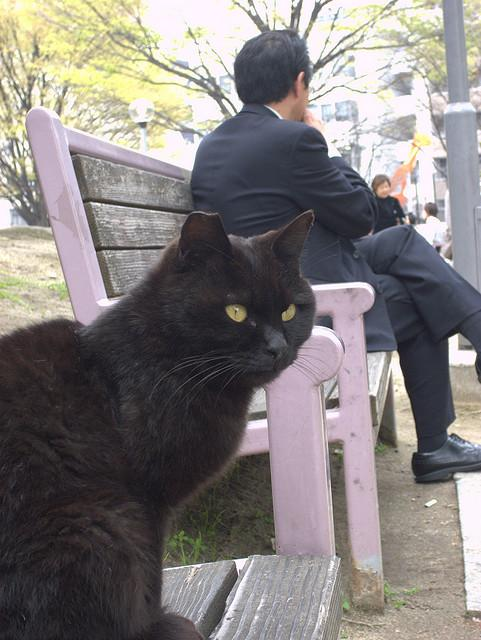What animal is on the bench? Please explain your reasoning. black cat. A cat is sitting on the bench. 